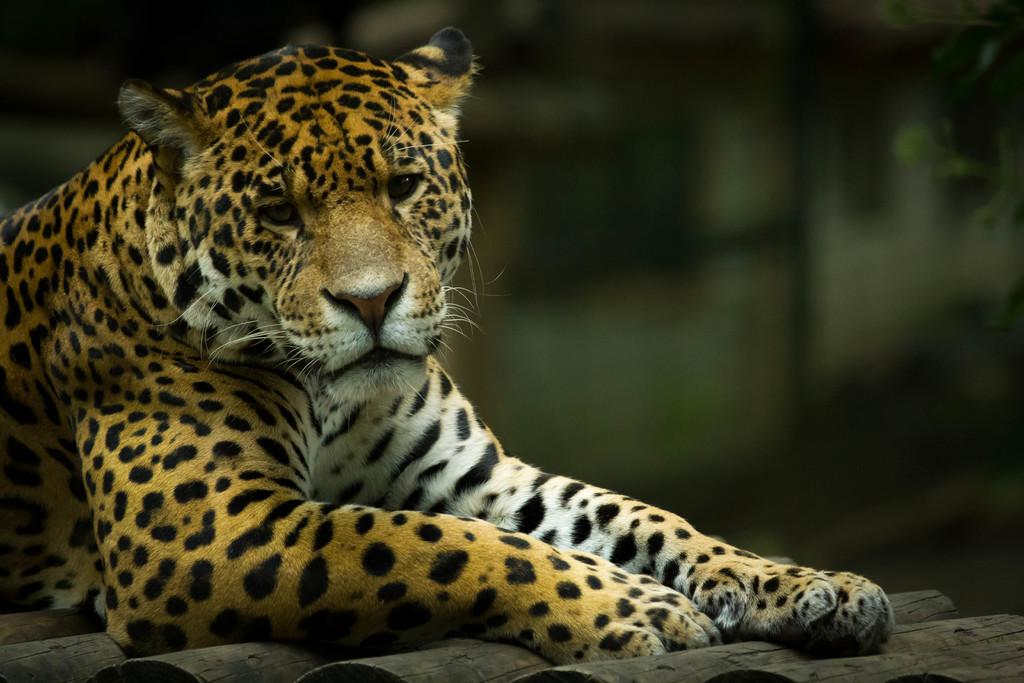What animal is the main subject of the picture? There is a cheetah in the picture. What is the cheetah sitting on? The cheetah is sitting on wooden sticks. How would you describe the background of the image? The background of the image is green and blurred. Where might this picture have been taken? The picture might have been taken in a forest, given the green background. How many rabbits can be seen driving a car in the image? There are no rabbits or cars present in the image; it features a cheetah sitting on wooden sticks. 